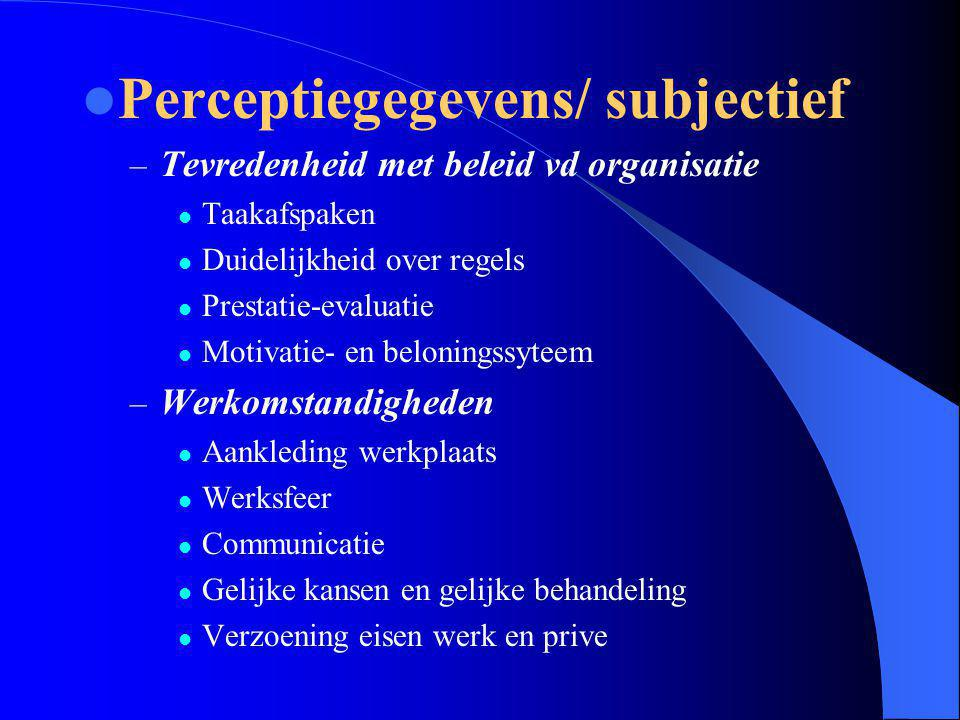How could the aspect of 'Werkomstandigheden' influence employee satisfaction in an organization? 'Werkomstandigheden,' or work conditions, significantly influence employee satisfaction as they encompass the physical and psychological environment in which employees operate. Factors like the aesthetic and functionality of the workplace, interpersonal relations, and the availability of resources all impact the overall comfort and well-being of employees, directly affecting their motivation and productivity. 